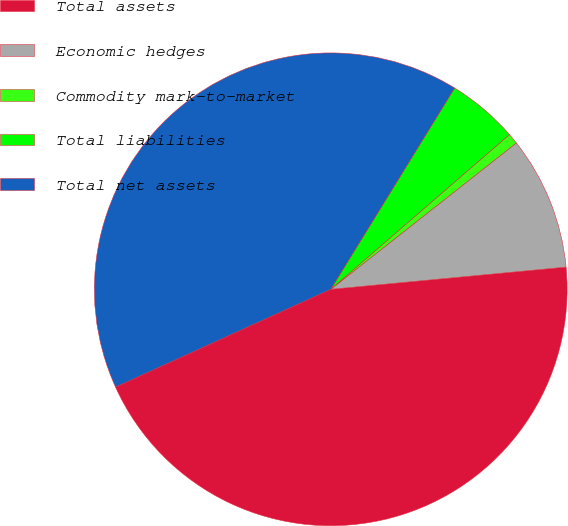Convert chart to OTSL. <chart><loc_0><loc_0><loc_500><loc_500><pie_chart><fcel>Total assets<fcel>Economic hedges<fcel>Commodity mark-to-market<fcel>Total liabilities<fcel>Total net assets<nl><fcel>44.71%<fcel>9.13%<fcel>0.73%<fcel>4.86%<fcel>40.57%<nl></chart> 